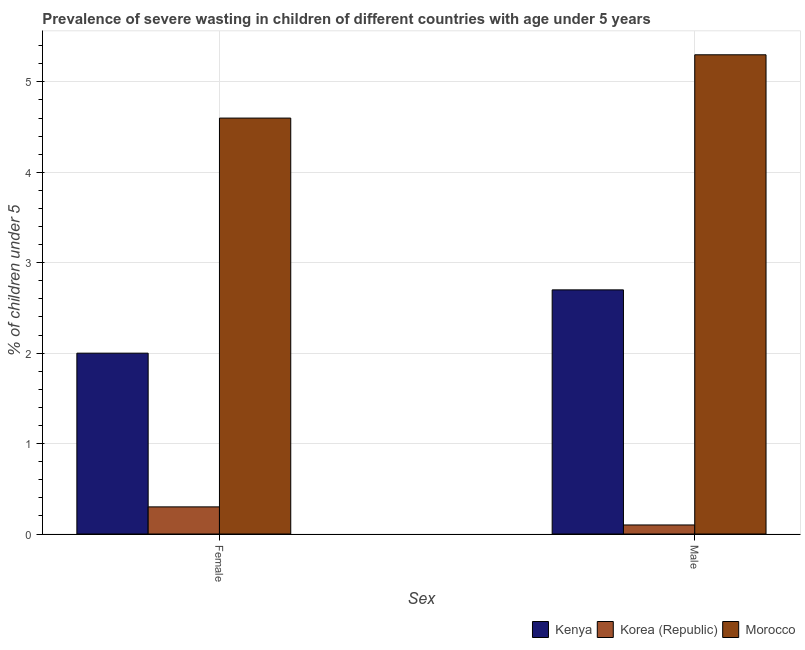How many bars are there on the 2nd tick from the right?
Provide a short and direct response. 3. What is the label of the 1st group of bars from the left?
Provide a succinct answer. Female. What is the percentage of undernourished female children in Kenya?
Ensure brevity in your answer.  2. Across all countries, what is the maximum percentage of undernourished female children?
Your answer should be very brief. 4.6. Across all countries, what is the minimum percentage of undernourished female children?
Offer a very short reply. 0.3. In which country was the percentage of undernourished female children maximum?
Your response must be concise. Morocco. In which country was the percentage of undernourished male children minimum?
Your answer should be compact. Korea (Republic). What is the total percentage of undernourished male children in the graph?
Your answer should be compact. 8.1. What is the difference between the percentage of undernourished female children in Kenya and that in Korea (Republic)?
Keep it short and to the point. 1.7. What is the difference between the percentage of undernourished female children in Korea (Republic) and the percentage of undernourished male children in Morocco?
Offer a very short reply. -5. What is the average percentage of undernourished female children per country?
Make the answer very short. 2.3. What is the difference between the percentage of undernourished male children and percentage of undernourished female children in Kenya?
Your answer should be very brief. 0.7. What is the ratio of the percentage of undernourished female children in Morocco to that in Kenya?
Your answer should be very brief. 2.3. Is the percentage of undernourished female children in Kenya less than that in Morocco?
Your response must be concise. Yes. What does the 1st bar from the right in Female represents?
Give a very brief answer. Morocco. Are all the bars in the graph horizontal?
Provide a succinct answer. No. What is the difference between two consecutive major ticks on the Y-axis?
Provide a succinct answer. 1. Does the graph contain grids?
Make the answer very short. Yes. Where does the legend appear in the graph?
Give a very brief answer. Bottom right. How many legend labels are there?
Provide a succinct answer. 3. How are the legend labels stacked?
Your answer should be compact. Horizontal. What is the title of the graph?
Your answer should be compact. Prevalence of severe wasting in children of different countries with age under 5 years. What is the label or title of the X-axis?
Make the answer very short. Sex. What is the label or title of the Y-axis?
Give a very brief answer.  % of children under 5. What is the  % of children under 5 of Korea (Republic) in Female?
Give a very brief answer. 0.3. What is the  % of children under 5 in Morocco in Female?
Make the answer very short. 4.6. What is the  % of children under 5 in Kenya in Male?
Your response must be concise. 2.7. What is the  % of children under 5 in Korea (Republic) in Male?
Make the answer very short. 0.1. What is the  % of children under 5 in Morocco in Male?
Make the answer very short. 5.3. Across all Sex, what is the maximum  % of children under 5 in Kenya?
Provide a short and direct response. 2.7. Across all Sex, what is the maximum  % of children under 5 of Korea (Republic)?
Ensure brevity in your answer.  0.3. Across all Sex, what is the maximum  % of children under 5 of Morocco?
Offer a very short reply. 5.3. Across all Sex, what is the minimum  % of children under 5 of Korea (Republic)?
Keep it short and to the point. 0.1. Across all Sex, what is the minimum  % of children under 5 in Morocco?
Make the answer very short. 4.6. What is the total  % of children under 5 of Korea (Republic) in the graph?
Offer a very short reply. 0.4. What is the total  % of children under 5 of Morocco in the graph?
Make the answer very short. 9.9. What is the difference between the  % of children under 5 of Kenya in Female and that in Male?
Offer a terse response. -0.7. What is the difference between the  % of children under 5 in Kenya in Female and the  % of children under 5 in Korea (Republic) in Male?
Ensure brevity in your answer.  1.9. What is the difference between the  % of children under 5 of Kenya in Female and the  % of children under 5 of Morocco in Male?
Your answer should be compact. -3.3. What is the average  % of children under 5 in Kenya per Sex?
Your answer should be very brief. 2.35. What is the average  % of children under 5 of Morocco per Sex?
Provide a short and direct response. 4.95. What is the difference between the  % of children under 5 of Kenya and  % of children under 5 of Korea (Republic) in Female?
Give a very brief answer. 1.7. What is the difference between the  % of children under 5 of Kenya and  % of children under 5 of Morocco in Female?
Your answer should be compact. -2.6. What is the difference between the  % of children under 5 of Kenya and  % of children under 5 of Morocco in Male?
Make the answer very short. -2.6. What is the ratio of the  % of children under 5 in Kenya in Female to that in Male?
Your answer should be very brief. 0.74. What is the ratio of the  % of children under 5 in Korea (Republic) in Female to that in Male?
Ensure brevity in your answer.  3. What is the ratio of the  % of children under 5 of Morocco in Female to that in Male?
Offer a very short reply. 0.87. What is the difference between the highest and the lowest  % of children under 5 in Kenya?
Make the answer very short. 0.7. 